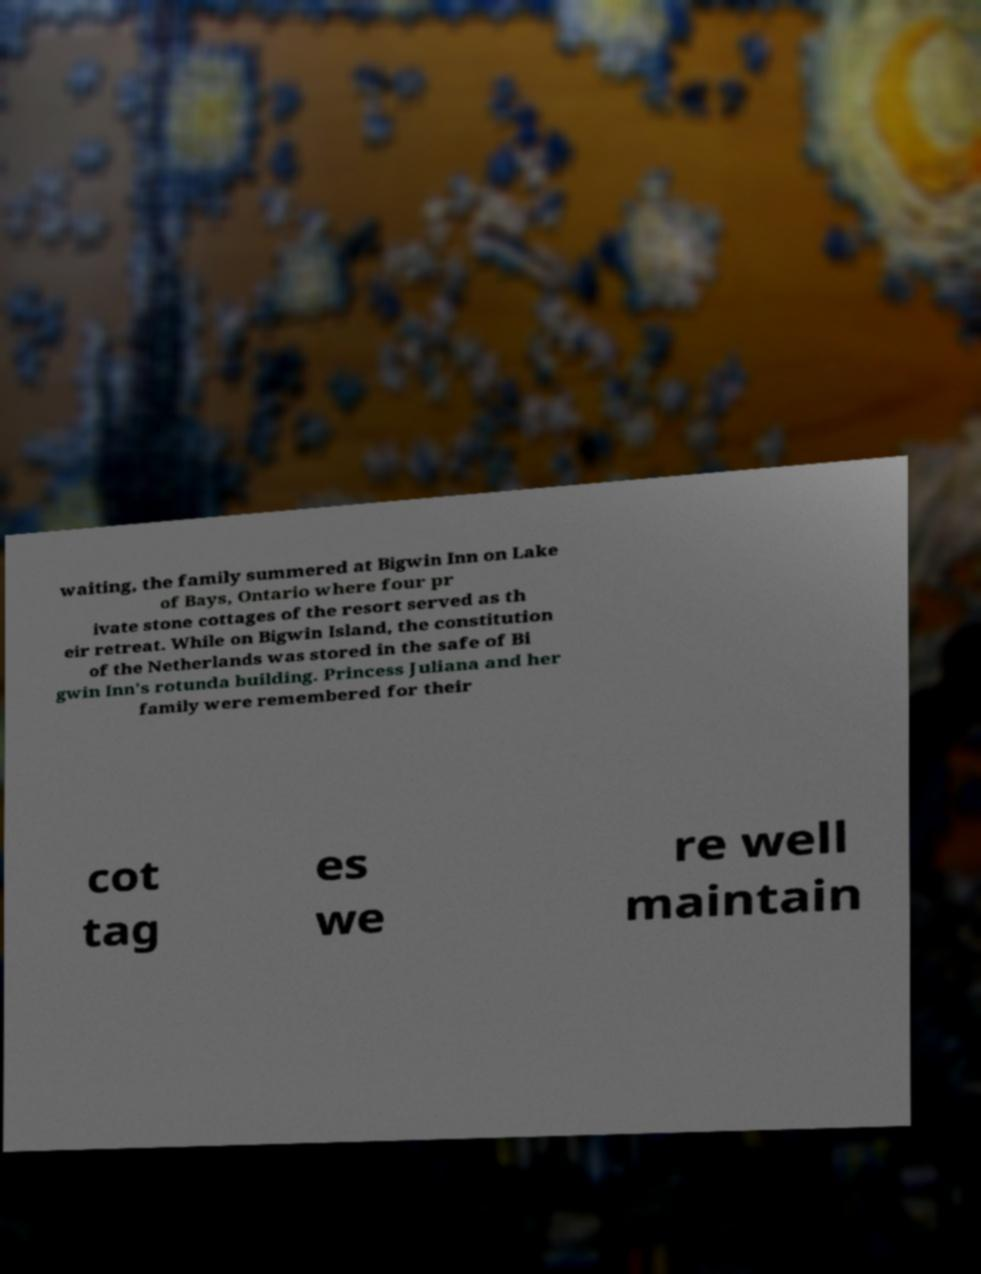Can you read and provide the text displayed in the image?This photo seems to have some interesting text. Can you extract and type it out for me? waiting, the family summered at Bigwin Inn on Lake of Bays, Ontario where four pr ivate stone cottages of the resort served as th eir retreat. While on Bigwin Island, the constitution of the Netherlands was stored in the safe of Bi gwin Inn's rotunda building. Princess Juliana and her family were remembered for their cot tag es we re well maintain 